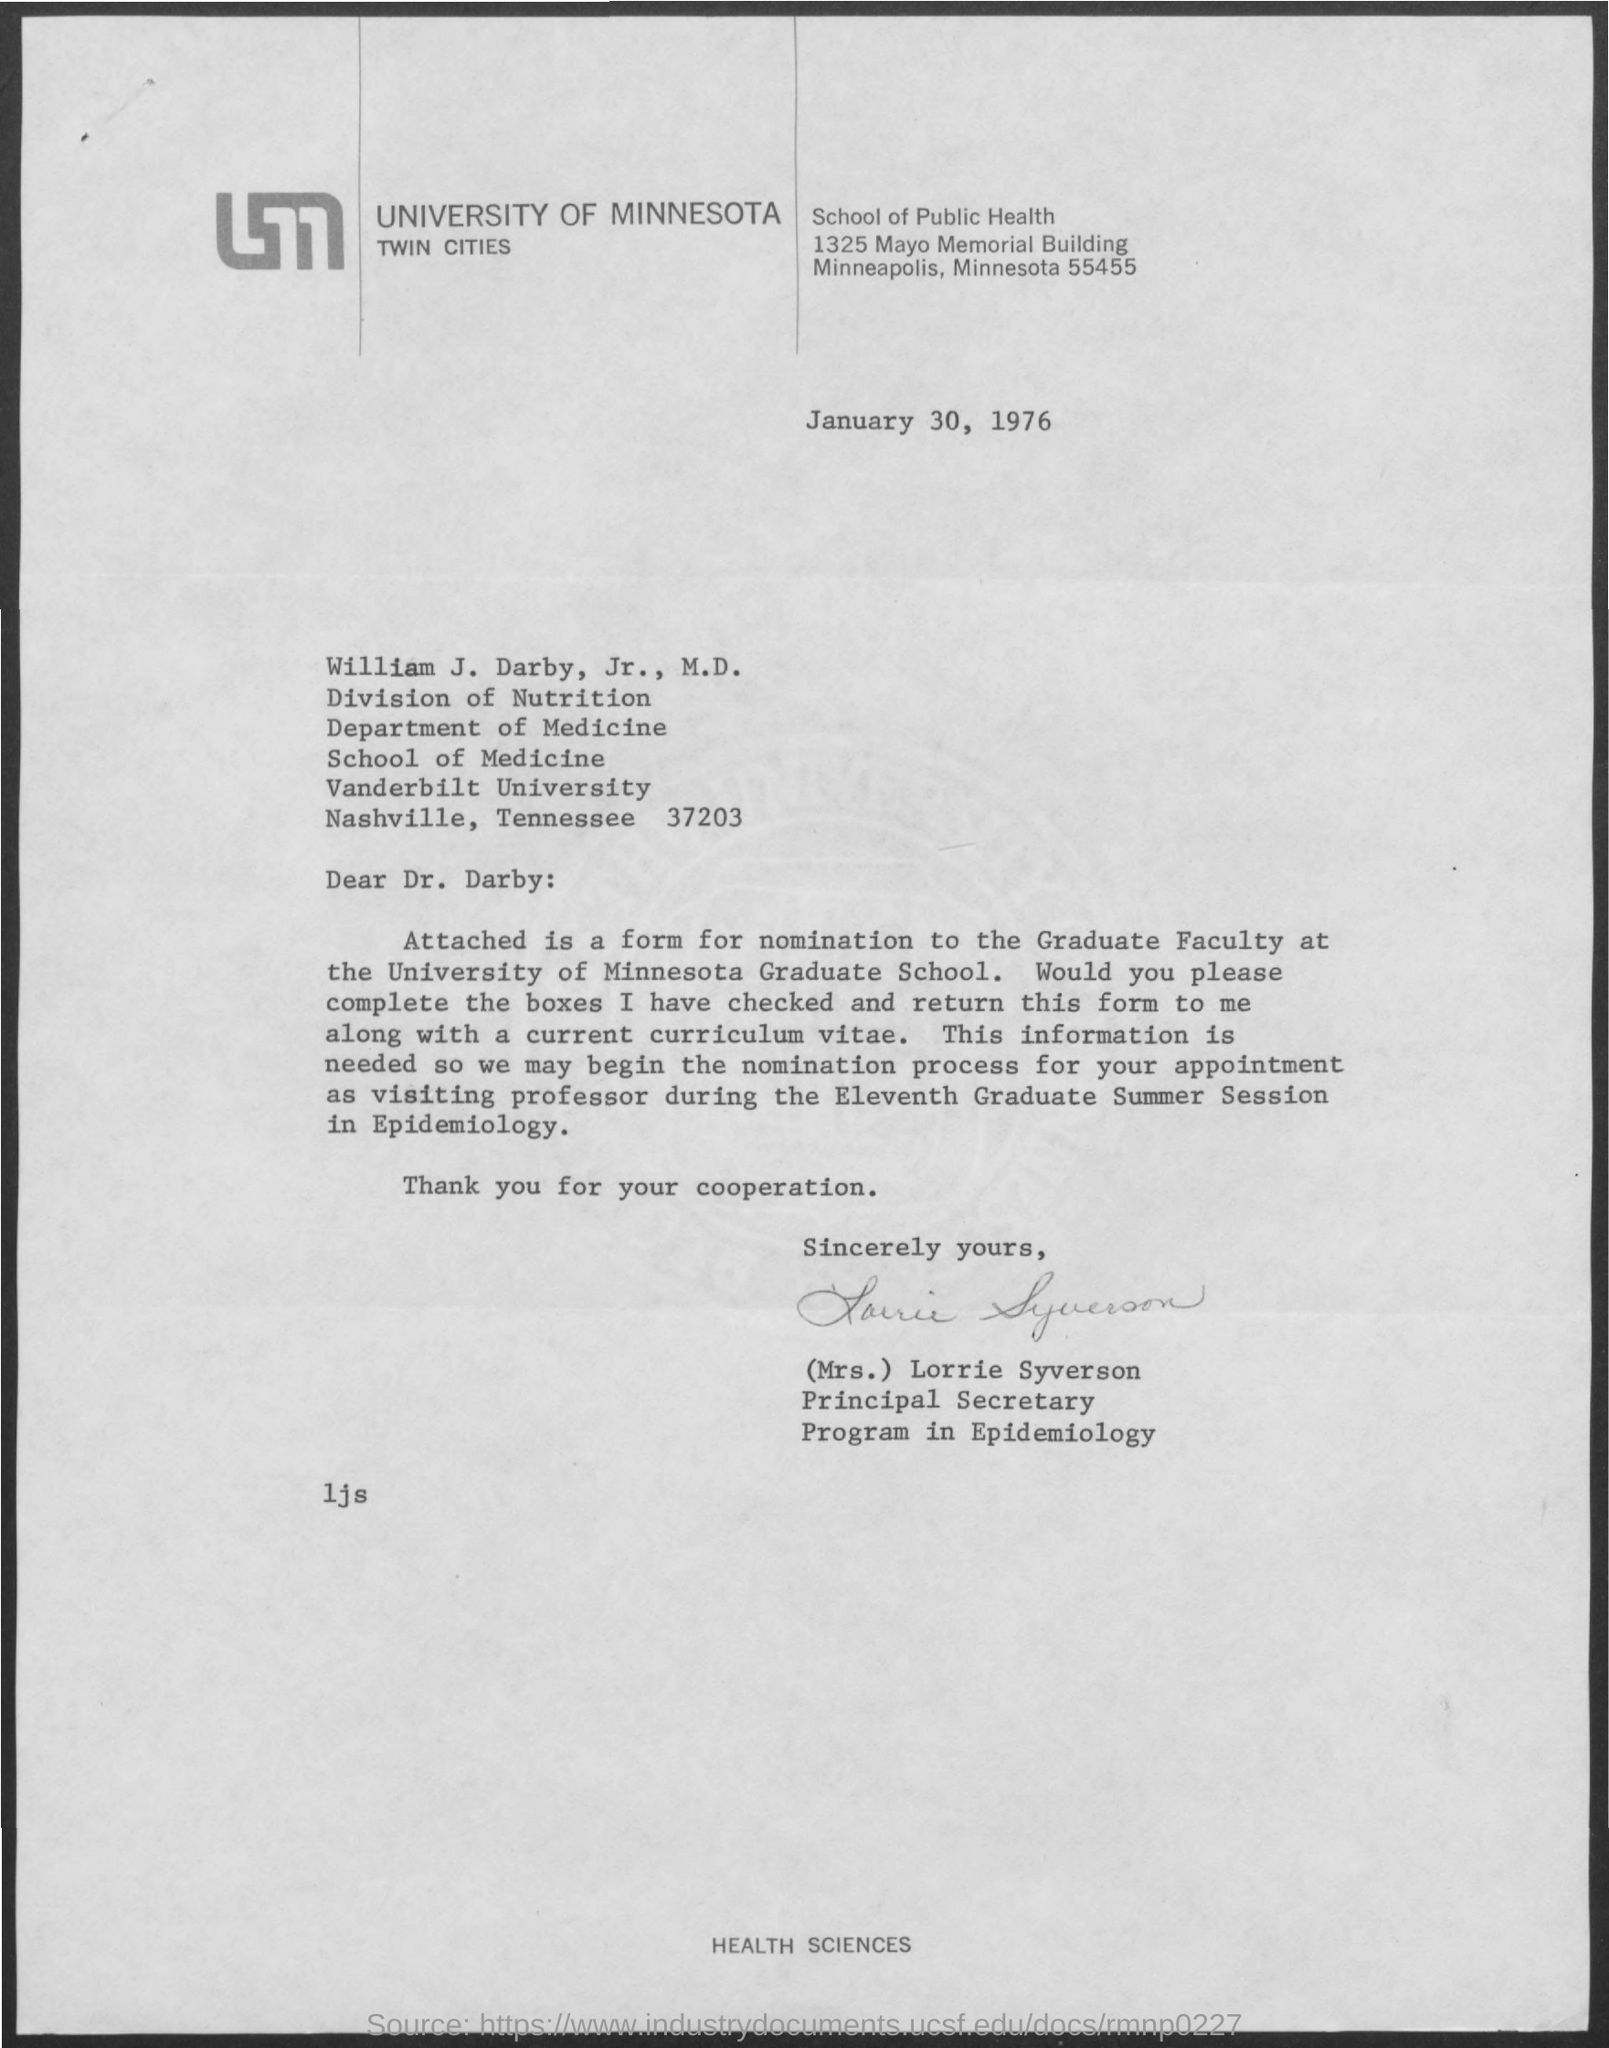What is the issued date of this letter?
Offer a very short reply. January 30, 1976. Which University is mentioned in the letter head?
Your answer should be very brief. University of minnesota. Who has signed this letter?
Offer a terse response. (Mrs.) Lorrie Syverson. 